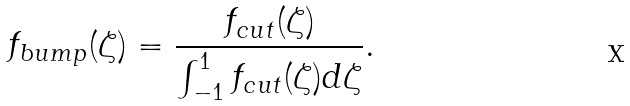<formula> <loc_0><loc_0><loc_500><loc_500>f _ { b u m p } ( \zeta ) = \frac { f _ { c u t } ( \zeta ) } { \int _ { - 1 } ^ { 1 } f _ { c u t } ( \zeta ) d \zeta } .</formula> 